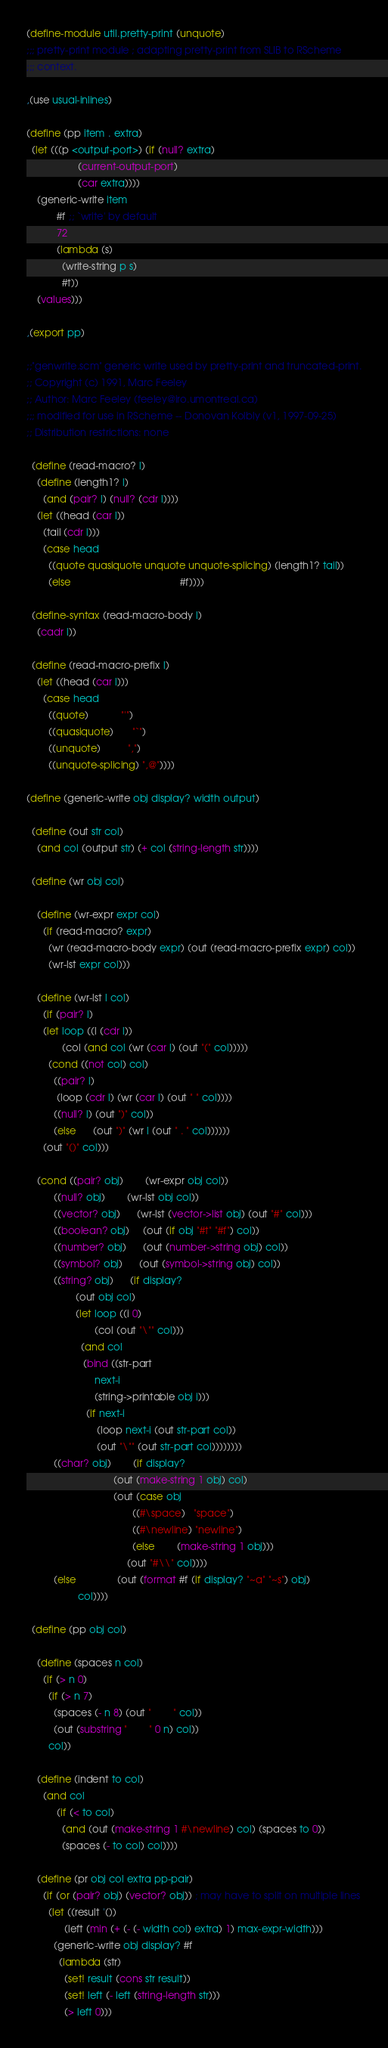<code> <loc_0><loc_0><loc_500><loc_500><_Scheme_>(define-module util.pretty-print (unquote)
;;; pretty-print module ; adapting pretty-print from SLIB to RScheme
;;; context.

,(use usual-inlines)

(define (pp item . extra)
  (let (((p <output-port>) (if (null? extra)
			       (current-output-port)
			       (car extra))))
    (generic-write item 
		   #f ;; `write' by default
		   72
		   (lambda (s)
		     (write-string p s)
		     #t))
    (values)))

,(export pp)

;;"genwrite.scm" generic write used by pretty-print and truncated-print.
;; Copyright (c) 1991, Marc Feeley
;; Author: Marc Feeley (feeley@iro.umontreal.ca)
;;; modified for use in RScheme -- Donovan Kolbly (v1, 1997-09-25)
;; Distribution restrictions: none

  (define (read-macro? l)
    (define (length1? l) 
      (and (pair? l) (null? (cdr l))))
    (let ((head (car l)) 
	  (tail (cdr l)))
      (case head
        ((quote quasiquote unquote unquote-splicing) (length1? tail))
        (else                                        #f))))

  (define-syntax (read-macro-body l)
    (cadr l))

  (define (read-macro-prefix l)
    (let ((head (car l)))
      (case head
        ((quote)            "'")
        ((quasiquote)       "`")
        ((unquote)          ",")
        ((unquote-splicing) ",@"))))

(define (generic-write obj display? width output)

  (define (out str col)
    (and col (output str) (+ col (string-length str))))

  (define (wr obj col)

    (define (wr-expr expr col)
      (if (read-macro? expr)
        (wr (read-macro-body expr) (out (read-macro-prefix expr) col))
        (wr-lst expr col)))

    (define (wr-lst l col)
      (if (pair? l)
	  (let loop ((l (cdr l))
		     (col (and col (wr (car l) (out "(" col)))))
	    (cond ((not col) col)
		  ((pair? l)
		   (loop (cdr l) (wr (car l) (out " " col))))
		  ((null? l) (out ")" col))
		  (else      (out ")" (wr l (out " . " col))))))
	  (out "()" col)))

    (cond ((pair? obj)        (wr-expr obj col))
          ((null? obj)        (wr-lst obj col))
          ((vector? obj)      (wr-lst (vector->list obj) (out "#" col)))
          ((boolean? obj)     (out (if obj "#t" "#f") col))
          ((number? obj)      (out (number->string obj) col))
          ((symbol? obj)      (out (symbol->string obj) col))
          ((string? obj)      (if display?
				  (out obj col)
				  (let loop ((i 0)
					     (col (out "\"" col)))
				    (and col
					 (bind ((str-part 
						 next-i
						 (string->printable obj i)))
					  (if next-i
					      (loop next-i (out str-part col))
					      (out "\"" (out str-part col))))))))
          ((char? obj)        (if display?
                                (out (make-string 1 obj) col)
                                (out (case obj
                                       ((#\space)   "space")
                                       ((#\newline) "newline")
                                       (else        (make-string 1 obj)))
                                     (out "#\\" col))))
          (else               (out (format #f (if display? "~a" "~s") obj)
				   col))))

  (define (pp obj col)

    (define (spaces n col)
      (if (> n 0)
        (if (> n 7)
          (spaces (- n 8) (out "        " col))
          (out (substring "        " 0 n) col))
        col))

    (define (indent to col)
      (and col
           (if (< to col)
             (and (out (make-string 1 #\newline) col) (spaces to 0))
             (spaces (- to col) col))))

    (define (pr obj col extra pp-pair)
      (if (or (pair? obj) (vector? obj)) ; may have to split on multiple lines
        (let ((result '())
              (left (min (+ (- (- width col) extra) 1) max-expr-width)))
          (generic-write obj display? #f
            (lambda (str)
              (set! result (cons str result))
              (set! left (- left (string-length str)))
              (> left 0)))</code> 